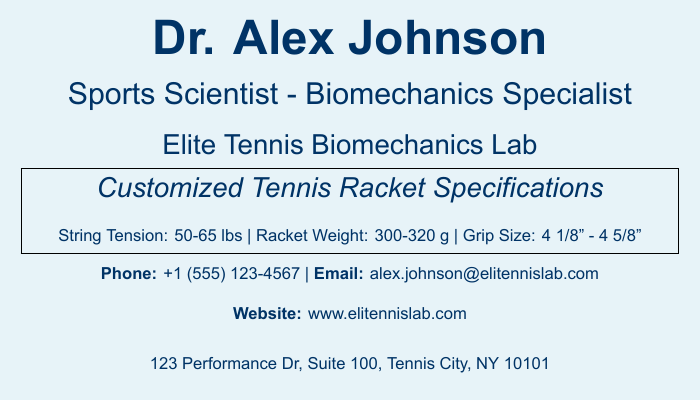what is the name of the sports scientist? The name is prominently displayed at the top of the document.
Answer: Dr. Alex Johnson what is the role of Dr. Alex Johnson? The role is indicated below the name on the document.
Answer: Sports Scientist - Biomechanics Specialist what is the string tension range provided? The range is specified in the customized specifications section of the document.
Answer: 50-65 lbs what is the weight range of the racket? The weight range is also provided in the specifications section of the document.
Answer: 300-320 g what is the grip size range mentioned? The grip size range is listed in the customized specifications.
Answer: 4 1/8" - 4 5/8" what is the contact email for Dr. Alex Johnson? The email is listed towards the bottom of the document.
Answer: alex.johnson@elitennislab.com how is performance enhanced according to the document? This is mentioned near the end of the document under the address.
Answer: Through biomechanical analysis what is the address of the Elite Tennis Biomechanics Lab? The complete address is provided at the bottom of the document.
Answer: 123 Performance Dr, Suite 100, Tennis City, NY 10101 what service does the Elite Tennis Biomechanics Lab focus on? This service is briefly mentioned just below the address.
Answer: Designing rackets for optimal comfort and injury prevention 